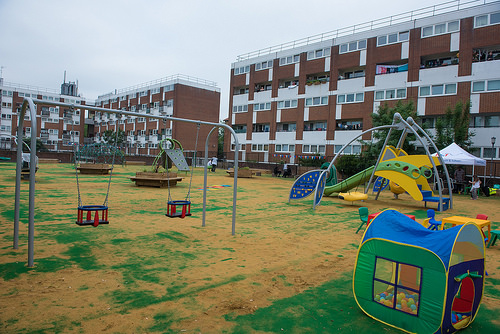<image>
Is there a play house in front of the play ground? Yes. The play house is positioned in front of the play ground, appearing closer to the camera viewpoint. 